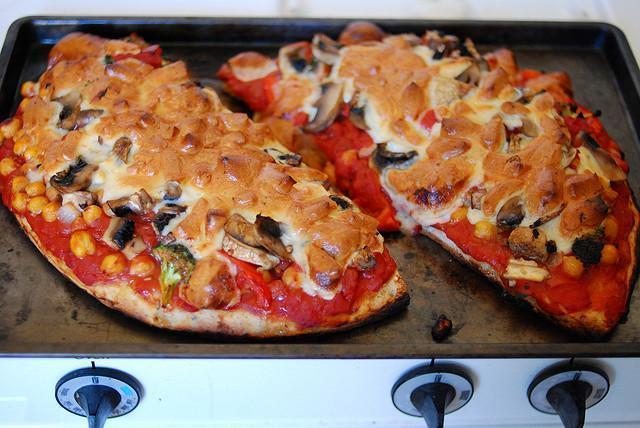What are the round things on the outer edge?
Indicate the correct response and explain using: 'Answer: answer
Rationale: rationale.'
Options: Garbanzo beans, peas, olives, cheese balls. Answer: garbanzo beans.
Rationale: They have added garbanzo beans to their pizza 